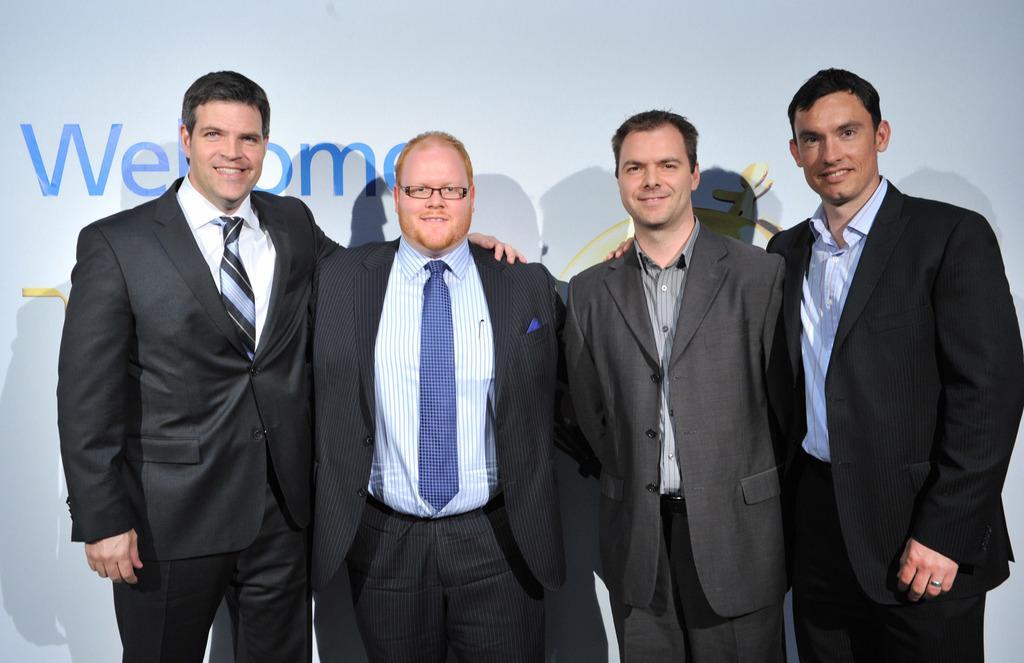Can you describe this image briefly? In this image we can see four persons. They are wearing a suit and a tie. They are smiling. 